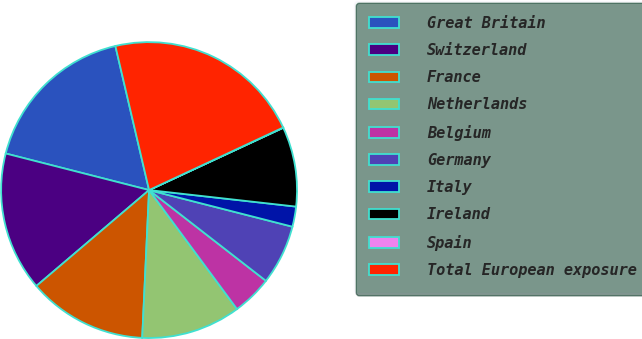Convert chart to OTSL. <chart><loc_0><loc_0><loc_500><loc_500><pie_chart><fcel>Great Britain<fcel>Switzerland<fcel>France<fcel>Netherlands<fcel>Belgium<fcel>Germany<fcel>Italy<fcel>Ireland<fcel>Spain<fcel>Total European exposure<nl><fcel>17.37%<fcel>15.2%<fcel>13.04%<fcel>10.87%<fcel>4.36%<fcel>6.53%<fcel>2.2%<fcel>8.7%<fcel>0.03%<fcel>21.71%<nl></chart> 